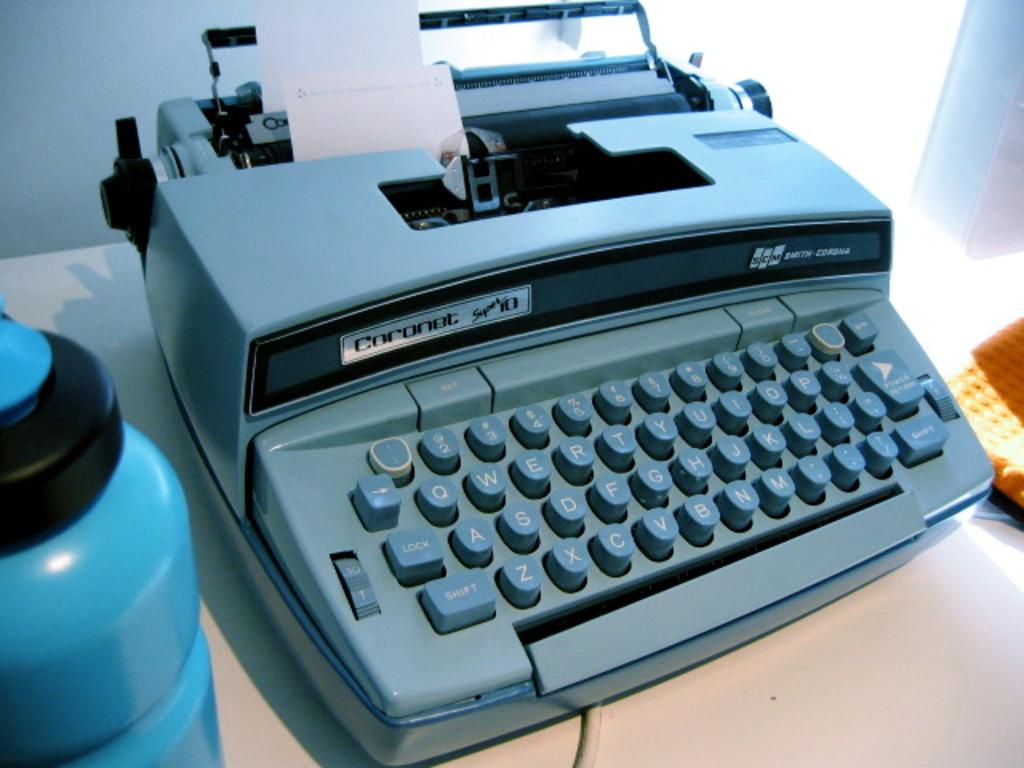Is this a type writer?
Provide a succinct answer. Answering does not require reading text in the image. What is the bottom left key?
Provide a succinct answer. Shift. 